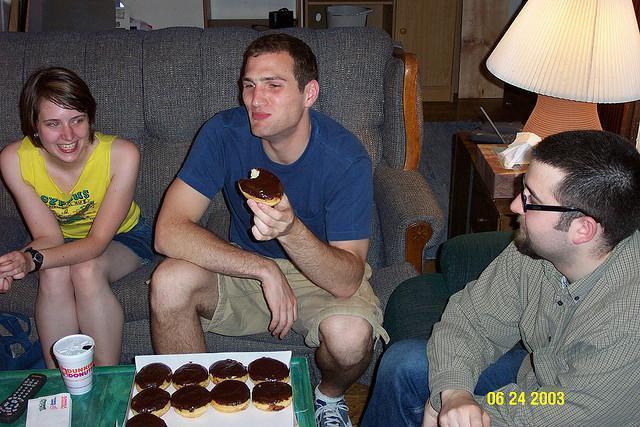How many women are eating pizza?
Give a very brief answer. 0. How many people can be seen?
Give a very brief answer. 3. How many couches are in the photo?
Give a very brief answer. 2. 